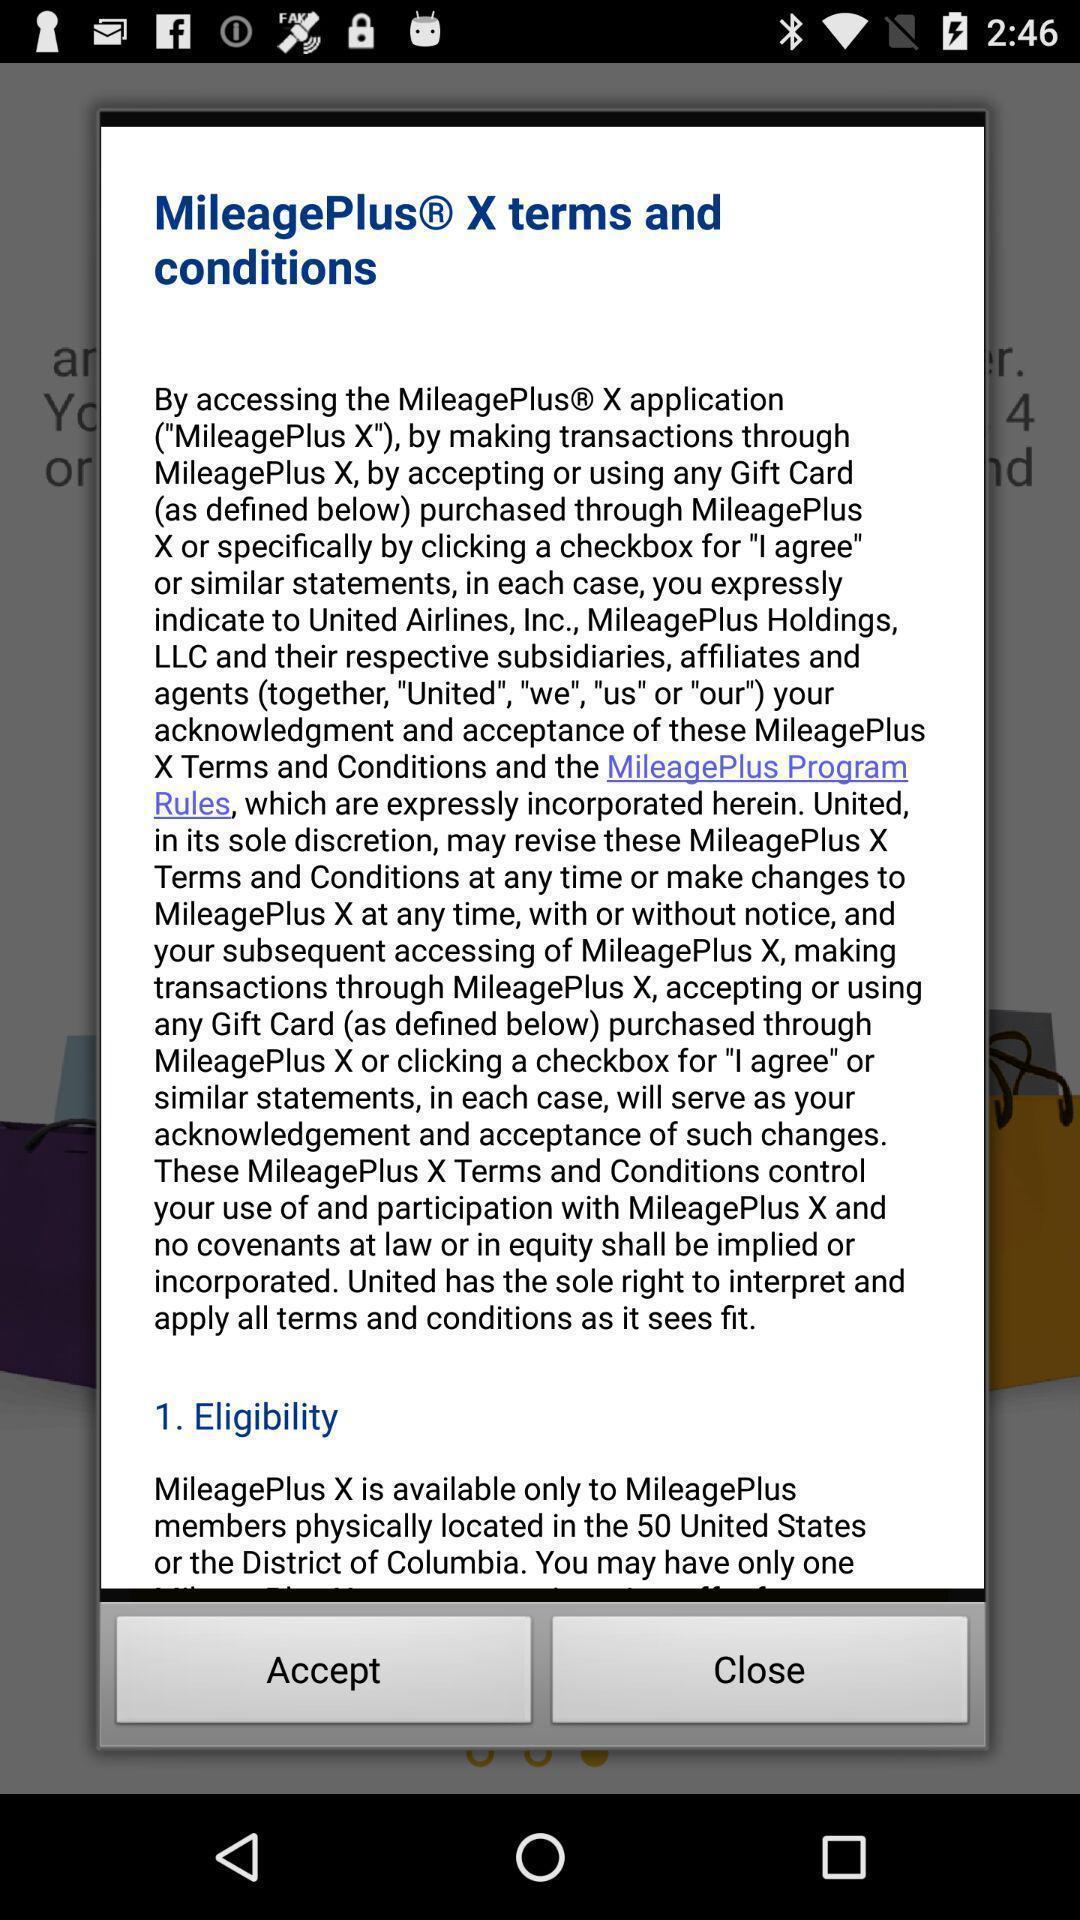Please provide a description for this image. Push up displaying terms and conditions for travel app. 